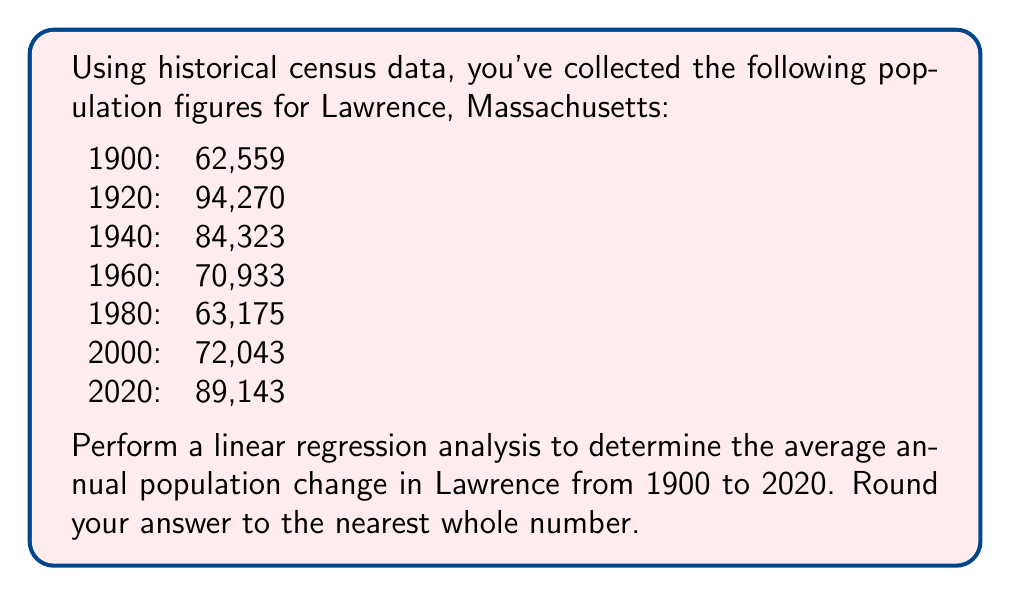Can you solve this math problem? To perform linear regression, we'll use the following steps:

1. Let $x$ represent the number of years since 1900, and $y$ represent the population.

2. Calculate the means of $x$ and $y$:
   $\bar{x} = \frac{0 + 20 + 40 + 60 + 80 + 100 + 120}{7} = 60$
   $\bar{y} = \frac{62559 + 94270 + 84323 + 70933 + 63175 + 72043 + 89143}{7} = 76635$

3. Calculate $\sum(x - \bar{x})(y - \bar{y})$ and $\sum(x - \bar{x})^2$:
   $\sum(x - \bar{x})(y - \bar{y}) = -3503760$
   $\sum(x - \bar{x})^2 = 14000$

4. Calculate the slope (m) of the regression line:
   $m = \frac{\sum(x - \bar{x})(y - \bar{y})}{\sum(x - \bar{x})^2} = \frac{-3503760}{14000} = -250.27$

5. The slope represents the average change in population per year.

6. Round to the nearest whole number: -250
Answer: -250 